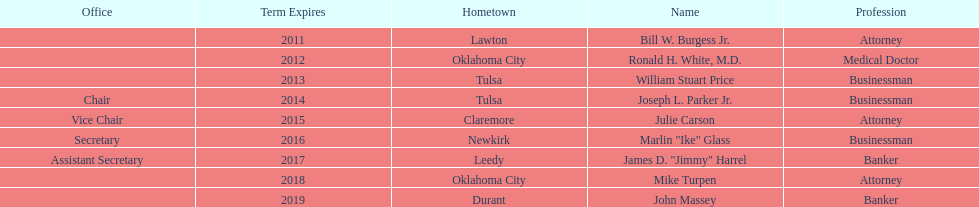Who are the regents? Bill W. Burgess Jr., Ronald H. White, M.D., William Stuart Price, Joseph L. Parker Jr., Julie Carson, Marlin "Ike" Glass, James D. "Jimmy" Harrel, Mike Turpen, John Massey. Of these who is a businessman? William Stuart Price, Joseph L. Parker Jr., Marlin "Ike" Glass. Of these whose hometown is tulsa? William Stuart Price, Joseph L. Parker Jr. Of these whose term expires in 2013? William Stuart Price. 